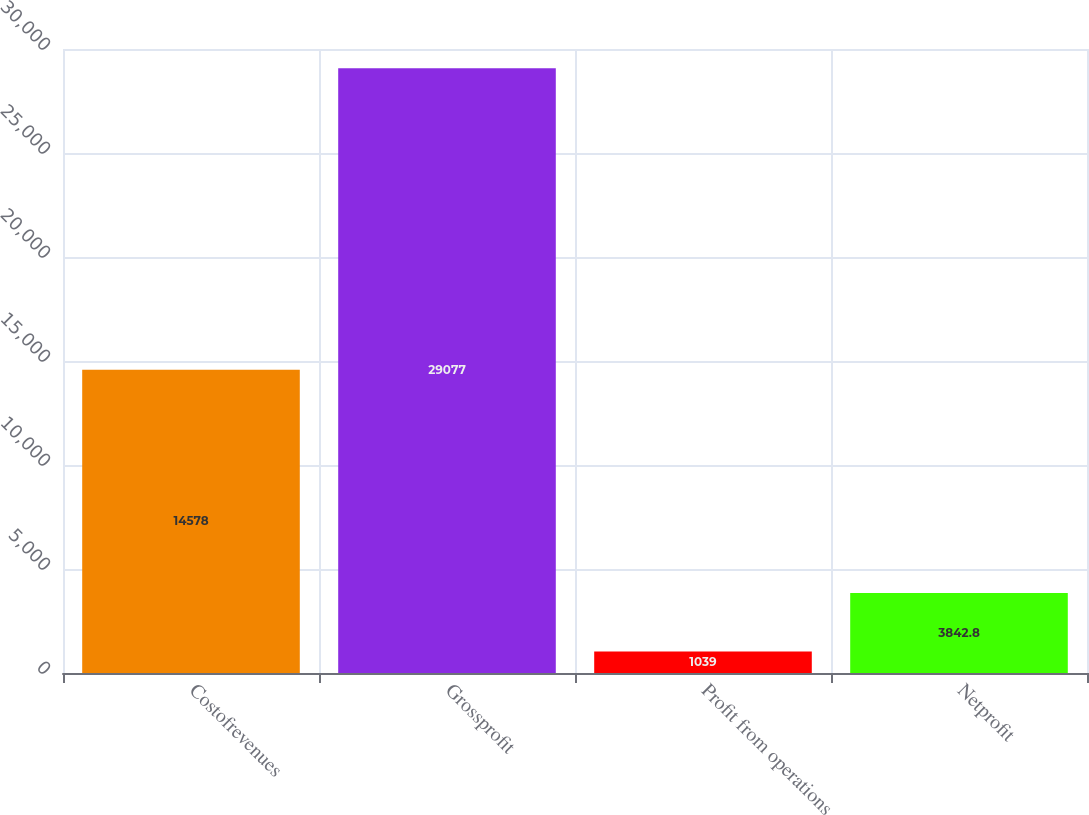<chart> <loc_0><loc_0><loc_500><loc_500><bar_chart><fcel>Costofrevenues<fcel>Grossprofit<fcel>Profit from operations<fcel>Netprofit<nl><fcel>14578<fcel>29077<fcel>1039<fcel>3842.8<nl></chart> 